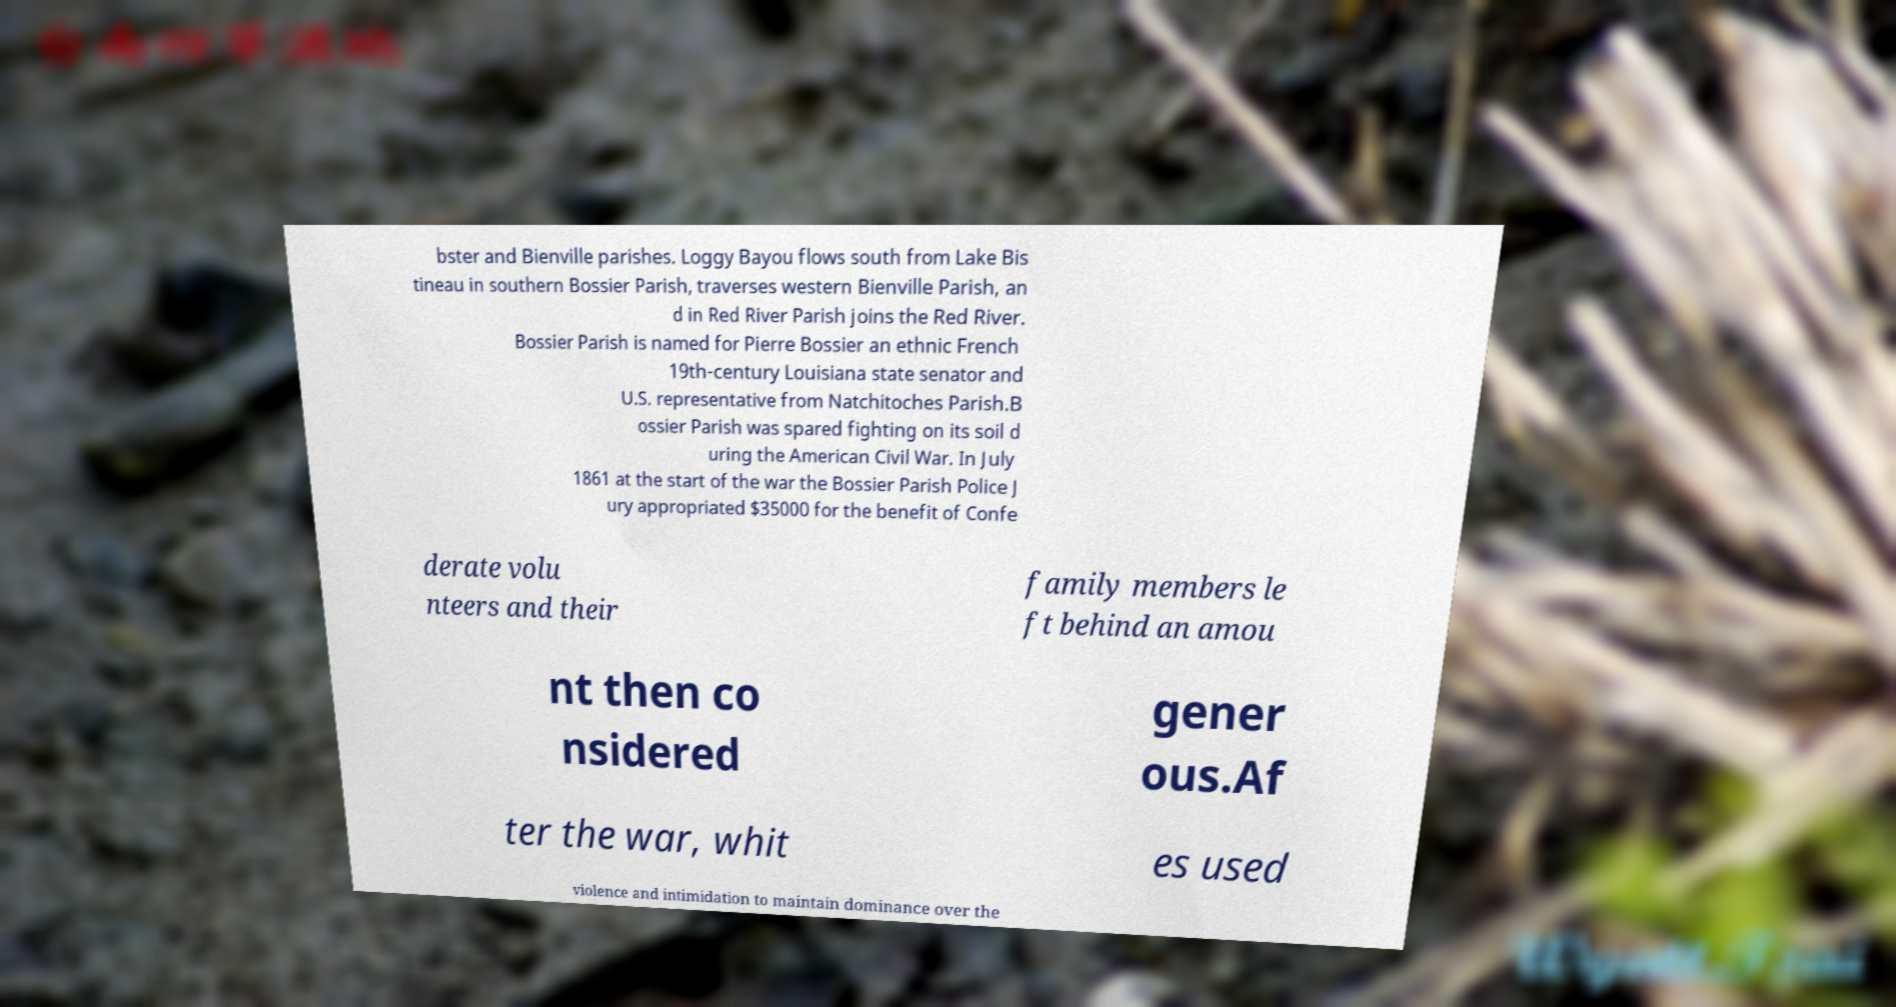Can you accurately transcribe the text from the provided image for me? bster and Bienville parishes. Loggy Bayou flows south from Lake Bis tineau in southern Bossier Parish, traverses western Bienville Parish, an d in Red River Parish joins the Red River. Bossier Parish is named for Pierre Bossier an ethnic French 19th-century Louisiana state senator and U.S. representative from Natchitoches Parish.B ossier Parish was spared fighting on its soil d uring the American Civil War. In July 1861 at the start of the war the Bossier Parish Police J ury appropriated $35000 for the benefit of Confe derate volu nteers and their family members le ft behind an amou nt then co nsidered gener ous.Af ter the war, whit es used violence and intimidation to maintain dominance over the 